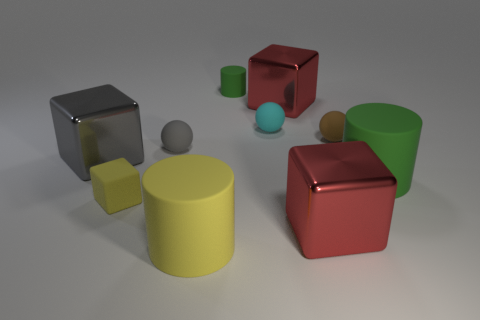Subtract all small brown matte balls. How many balls are left? 2 Subtract all green cylinders. How many cylinders are left? 1 Subtract 3 balls. How many balls are left? 0 Subtract 0 red cylinders. How many objects are left? 10 Subtract all blocks. How many objects are left? 6 Subtract all blue cylinders. Subtract all yellow blocks. How many cylinders are left? 3 Subtract all purple cylinders. How many green spheres are left? 0 Subtract all small cyan matte cylinders. Subtract all big gray cubes. How many objects are left? 9 Add 1 large green cylinders. How many large green cylinders are left? 2 Add 3 brown matte spheres. How many brown matte spheres exist? 4 